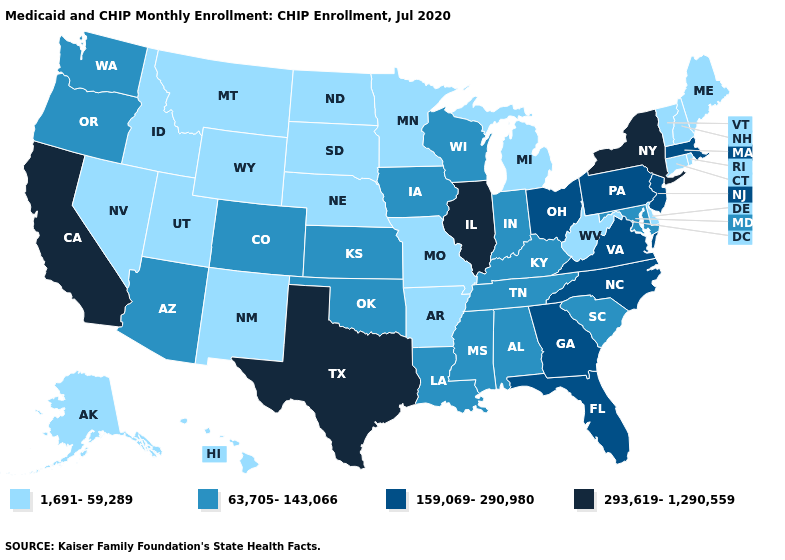Among the states that border Utah , which have the lowest value?
Quick response, please. Idaho, Nevada, New Mexico, Wyoming. Name the states that have a value in the range 1,691-59,289?
Answer briefly. Alaska, Arkansas, Connecticut, Delaware, Hawaii, Idaho, Maine, Michigan, Minnesota, Missouri, Montana, Nebraska, Nevada, New Hampshire, New Mexico, North Dakota, Rhode Island, South Dakota, Utah, Vermont, West Virginia, Wyoming. What is the value of North Carolina?
Short answer required. 159,069-290,980. Name the states that have a value in the range 159,069-290,980?
Give a very brief answer. Florida, Georgia, Massachusetts, New Jersey, North Carolina, Ohio, Pennsylvania, Virginia. What is the value of Ohio?
Give a very brief answer. 159,069-290,980. Does New Hampshire have the lowest value in the Northeast?
Write a very short answer. Yes. How many symbols are there in the legend?
Short answer required. 4. Name the states that have a value in the range 1,691-59,289?
Quick response, please. Alaska, Arkansas, Connecticut, Delaware, Hawaii, Idaho, Maine, Michigan, Minnesota, Missouri, Montana, Nebraska, Nevada, New Hampshire, New Mexico, North Dakota, Rhode Island, South Dakota, Utah, Vermont, West Virginia, Wyoming. Does Nebraska have the lowest value in the MidWest?
Short answer required. Yes. What is the value of Missouri?
Short answer required. 1,691-59,289. Among the states that border Maryland , does Delaware have the lowest value?
Quick response, please. Yes. What is the highest value in states that border Delaware?
Answer briefly. 159,069-290,980. Name the states that have a value in the range 63,705-143,066?
Quick response, please. Alabama, Arizona, Colorado, Indiana, Iowa, Kansas, Kentucky, Louisiana, Maryland, Mississippi, Oklahoma, Oregon, South Carolina, Tennessee, Washington, Wisconsin. 